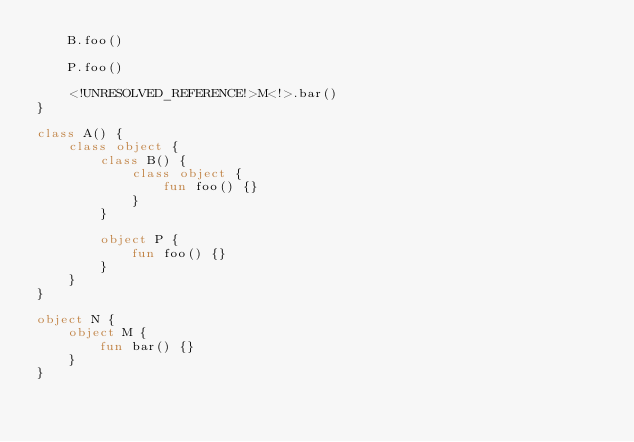<code> <loc_0><loc_0><loc_500><loc_500><_Kotlin_>    B.foo()

    P.foo()

    <!UNRESOLVED_REFERENCE!>M<!>.bar()
}

class A() {
    class object {
        class B() {
            class object {
                fun foo() {}
            }
        }

        object P {
            fun foo() {}
        }
    }
}

object N {
    object M {
        fun bar() {}
    }
}</code> 